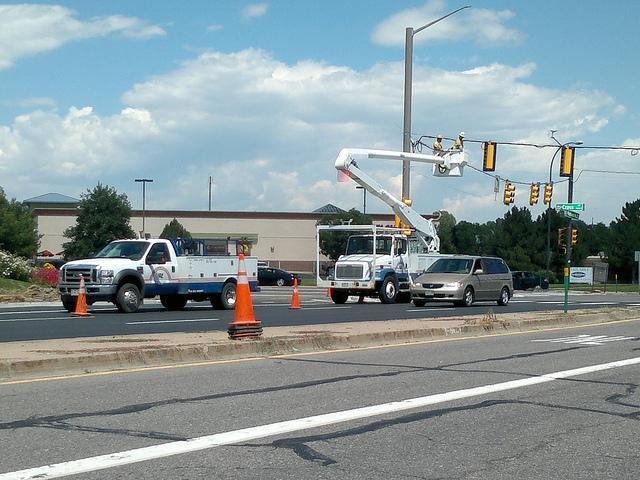How many men are in the cherry picker bucket?
Give a very brief answer. 2. How many trucks can be seen?
Give a very brief answer. 2. 